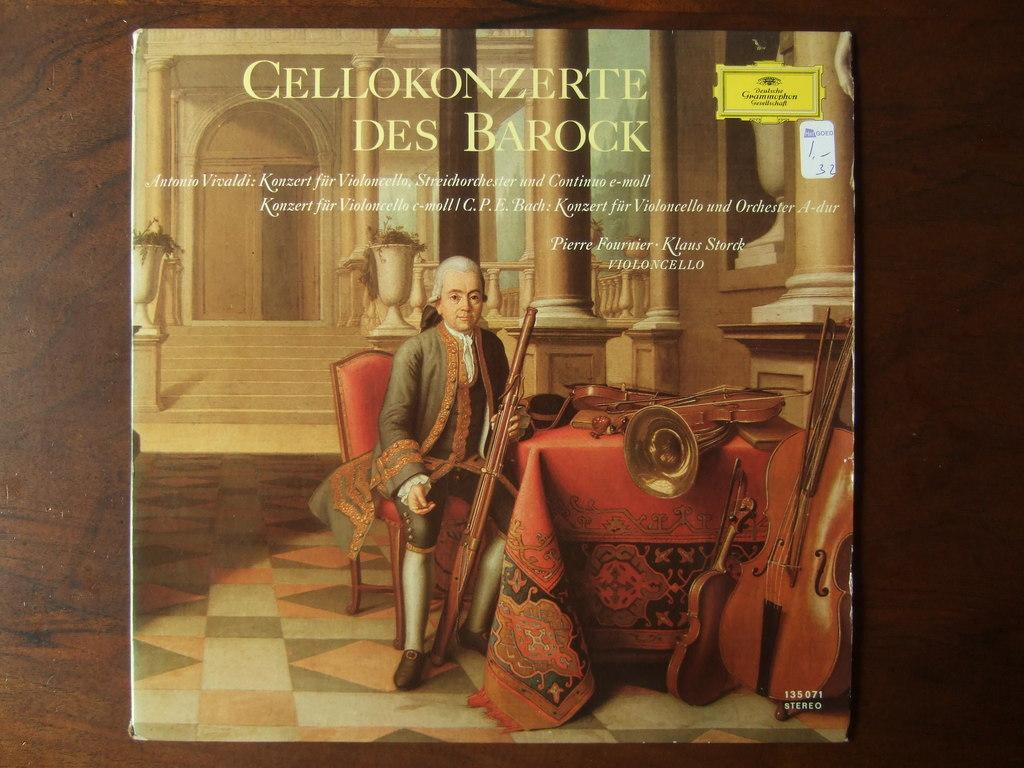Provide a one-sentence caption for the provided image. Cellokonzerte Des Barock album cover featuring a gentleman sitting next to various instruments. 